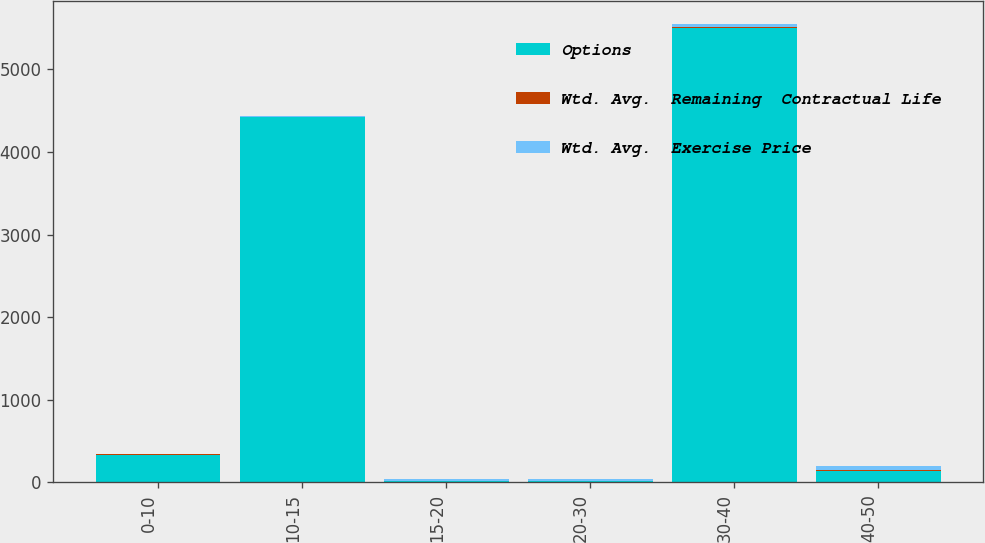<chart> <loc_0><loc_0><loc_500><loc_500><stacked_bar_chart><ecel><fcel>0-10<fcel>10-15<fcel>15-20<fcel>20-30<fcel>30-40<fcel>40-50<nl><fcel>Options<fcel>338<fcel>4418<fcel>14.585<fcel>14.585<fcel>5500<fcel>144<nl><fcel>Wtd. Avg.  Remaining  Contractual Life<fcel>0.51<fcel>2.46<fcel>5.17<fcel>6.85<fcel>8.76<fcel>9.79<nl><fcel>Wtd. Avg.  Exercise Price<fcel>8.87<fcel>12.96<fcel>16.21<fcel>24.46<fcel>34.75<fcel>41.41<nl></chart> 